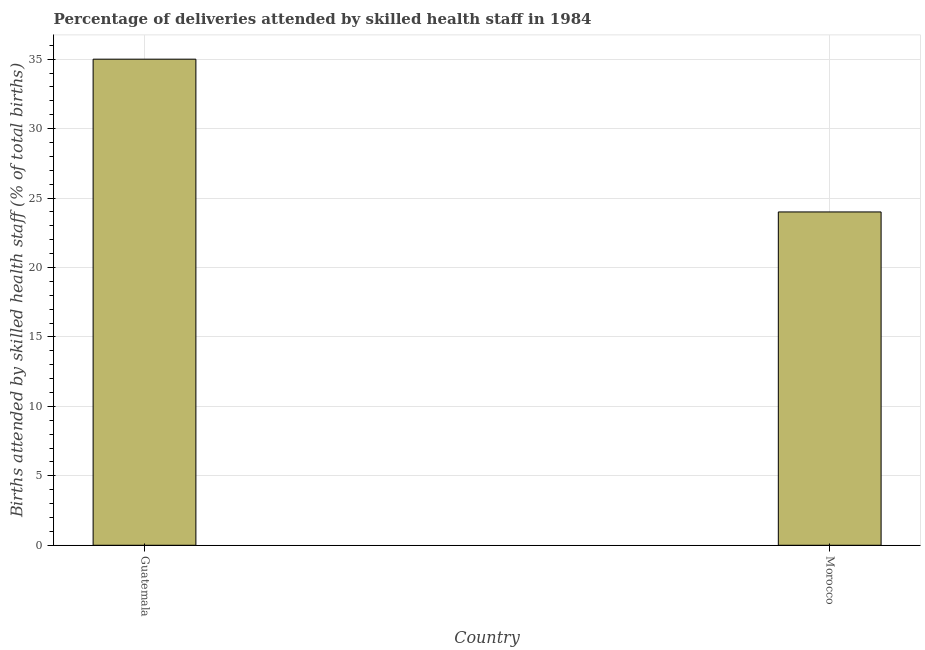Does the graph contain any zero values?
Make the answer very short. No. What is the title of the graph?
Your answer should be compact. Percentage of deliveries attended by skilled health staff in 1984. What is the label or title of the Y-axis?
Offer a terse response. Births attended by skilled health staff (% of total births). Across all countries, what is the minimum number of births attended by skilled health staff?
Provide a succinct answer. 24. In which country was the number of births attended by skilled health staff maximum?
Provide a succinct answer. Guatemala. In which country was the number of births attended by skilled health staff minimum?
Provide a short and direct response. Morocco. What is the sum of the number of births attended by skilled health staff?
Provide a succinct answer. 59. What is the average number of births attended by skilled health staff per country?
Provide a succinct answer. 29. What is the median number of births attended by skilled health staff?
Provide a short and direct response. 29.5. In how many countries, is the number of births attended by skilled health staff greater than 2 %?
Your answer should be very brief. 2. What is the ratio of the number of births attended by skilled health staff in Guatemala to that in Morocco?
Your answer should be very brief. 1.46. In how many countries, is the number of births attended by skilled health staff greater than the average number of births attended by skilled health staff taken over all countries?
Ensure brevity in your answer.  1. How many countries are there in the graph?
Your answer should be compact. 2. What is the Births attended by skilled health staff (% of total births) in Guatemala?
Ensure brevity in your answer.  35. What is the Births attended by skilled health staff (% of total births) in Morocco?
Make the answer very short. 24. What is the ratio of the Births attended by skilled health staff (% of total births) in Guatemala to that in Morocco?
Your answer should be very brief. 1.46. 